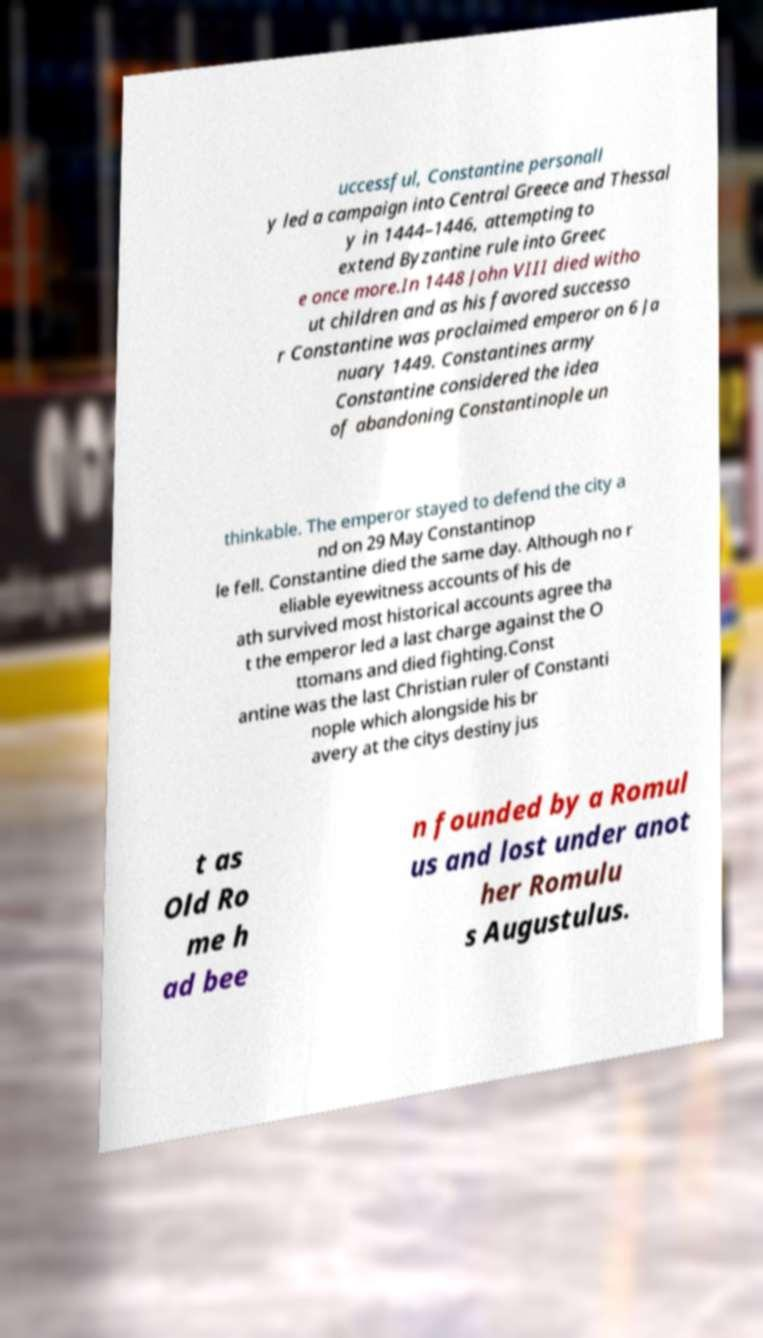There's text embedded in this image that I need extracted. Can you transcribe it verbatim? uccessful, Constantine personall y led a campaign into Central Greece and Thessal y in 1444–1446, attempting to extend Byzantine rule into Greec e once more.In 1448 John VIII died witho ut children and as his favored successo r Constantine was proclaimed emperor on 6 Ja nuary 1449. Constantines army Constantine considered the idea of abandoning Constantinople un thinkable. The emperor stayed to defend the city a nd on 29 May Constantinop le fell. Constantine died the same day. Although no r eliable eyewitness accounts of his de ath survived most historical accounts agree tha t the emperor led a last charge against the O ttomans and died fighting.Const antine was the last Christian ruler of Constanti nople which alongside his br avery at the citys destiny jus t as Old Ro me h ad bee n founded by a Romul us and lost under anot her Romulu s Augustulus. 